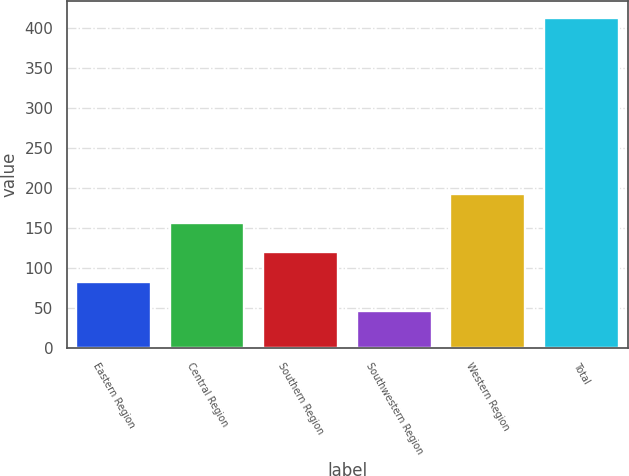Convert chart to OTSL. <chart><loc_0><loc_0><loc_500><loc_500><bar_chart><fcel>Eastern Region<fcel>Central Region<fcel>Southern Region<fcel>Southwestern Region<fcel>Western Region<fcel>Total<nl><fcel>83.12<fcel>156.36<fcel>119.74<fcel>46.5<fcel>192.98<fcel>412.7<nl></chart> 